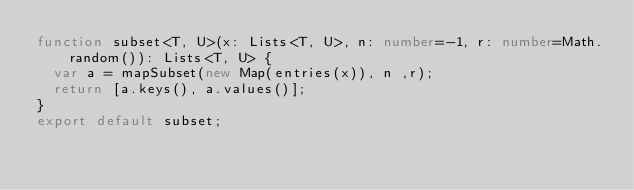Convert code to text. <code><loc_0><loc_0><loc_500><loc_500><_TypeScript_>function subset<T, U>(x: Lists<T, U>, n: number=-1, r: number=Math.random()): Lists<T, U> {
  var a = mapSubset(new Map(entries(x)), n ,r);
  return [a.keys(), a.values()];
}
export default subset;
</code> 